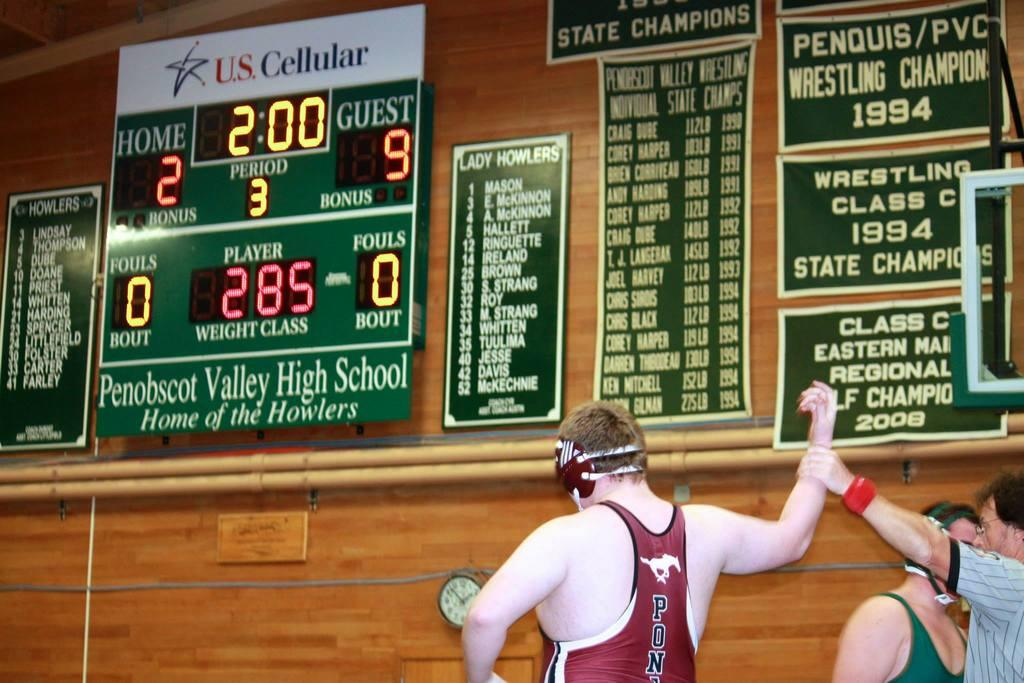<image>
Relay a brief, clear account of the picture shown. a wrestler in a gym setting with a scoreboard near them that has the number 9 on it 